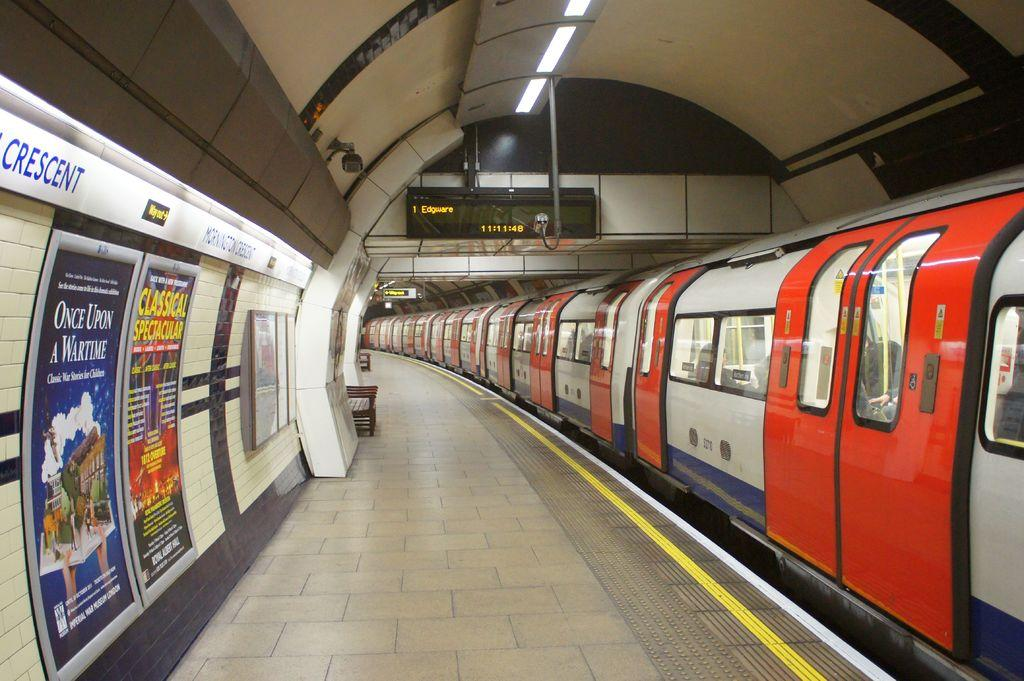Provide a one-sentence caption for the provided image. An ad for Once Upon a Wartime is on the wall of a subway station. 